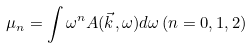<formula> <loc_0><loc_0><loc_500><loc_500>\mu _ { n } = \int \omega ^ { n } A ( \vec { k } , \omega ) d \omega \, ( n = 0 , 1 , 2 )</formula> 